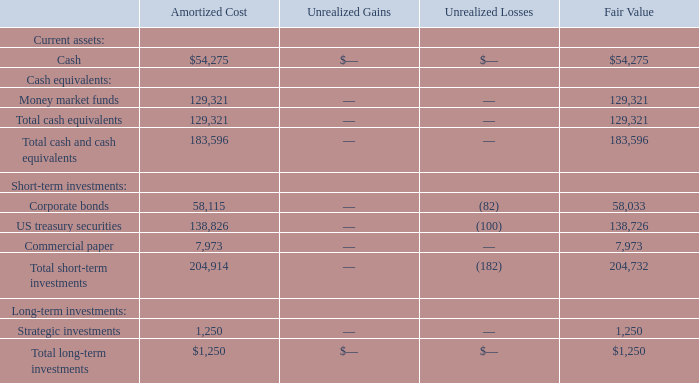The following is a summary of investments, including those that meet the definition of a cash equivalent, as of December 31, 2018 (in thousands):
As of December 31, 2019, the Company’s investment in corporate bonds and US treasury securities had a weighted-average maturity date of approximately five months. Unrealized gains and losses on investments were not significant individually or in aggregate, and the Company does not believe the unrealized losses represent other-than-temporary impairments as of December 31, 2019.
As of December 31, 2019, how long was the weighted-average maturity date of the Company's investment in corporate bonds and US treasury securities? Approximately five months. What was the total amortized cost of money market funds?
Answer scale should be: thousand. 129,321. What was the total amortized cost of corporate bonds?
Answer scale should be: thousand. 58,115. What was the sum of amortized cost of corporate bonds and US treasury securities?
Answer scale should be: thousand. 58,115+138,826
Answer: 196941. What percentage of total fair value of cash and cash equivalents consists of cash?
Answer scale should be: percent. (54,275/183,596)
Answer: 29.56. What percentage of total unrealized losses for short-term investments consist of corporate bonds?
Answer scale should be: percent. (82/182)
Answer: 45.05. 